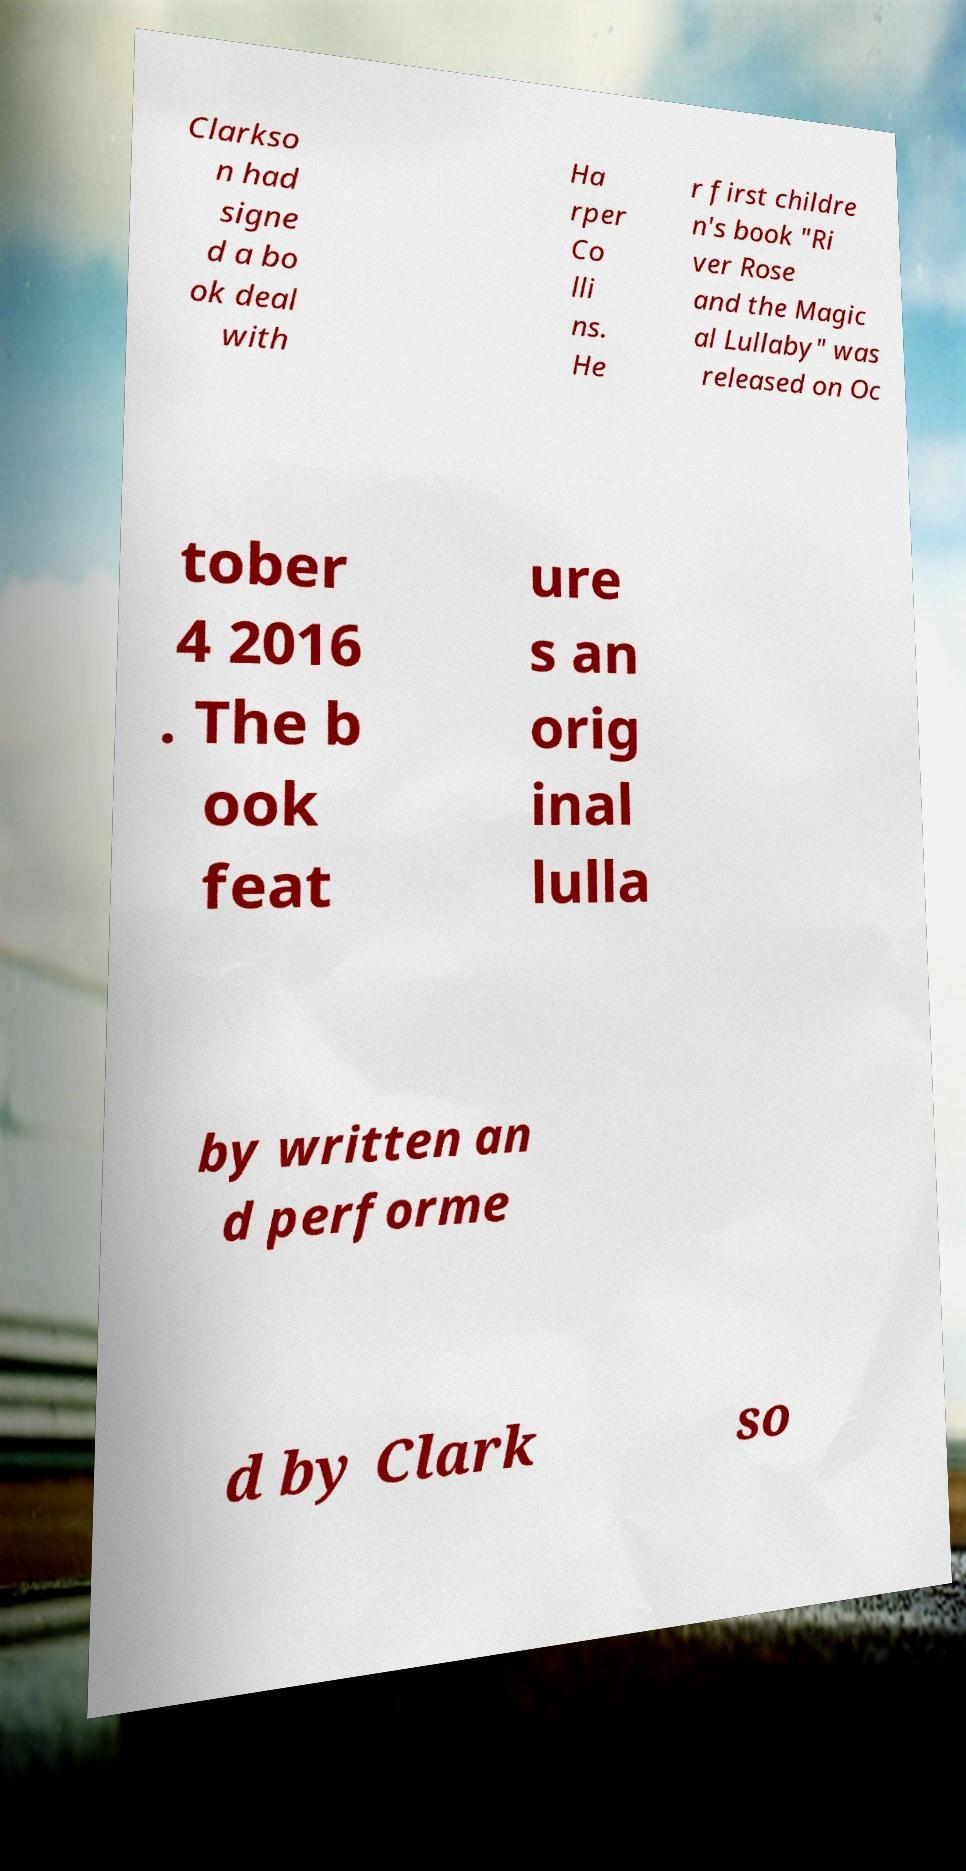There's text embedded in this image that I need extracted. Can you transcribe it verbatim? Clarkso n had signe d a bo ok deal with Ha rper Co lli ns. He r first childre n's book "Ri ver Rose and the Magic al Lullaby" was released on Oc tober 4 2016 . The b ook feat ure s an orig inal lulla by written an d performe d by Clark so 